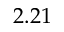Convert formula to latex. <formula><loc_0><loc_0><loc_500><loc_500>2 . 2 1</formula> 